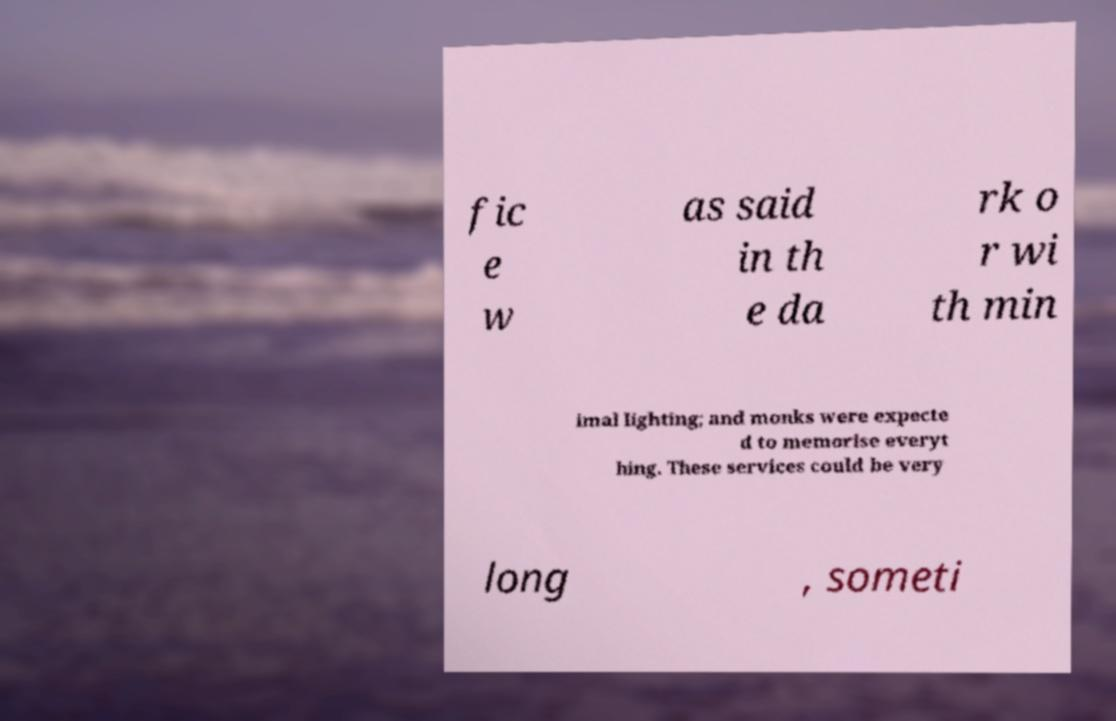What messages or text are displayed in this image? I need them in a readable, typed format. fic e w as said in th e da rk o r wi th min imal lighting; and monks were expecte d to memorise everyt hing. These services could be very long , someti 